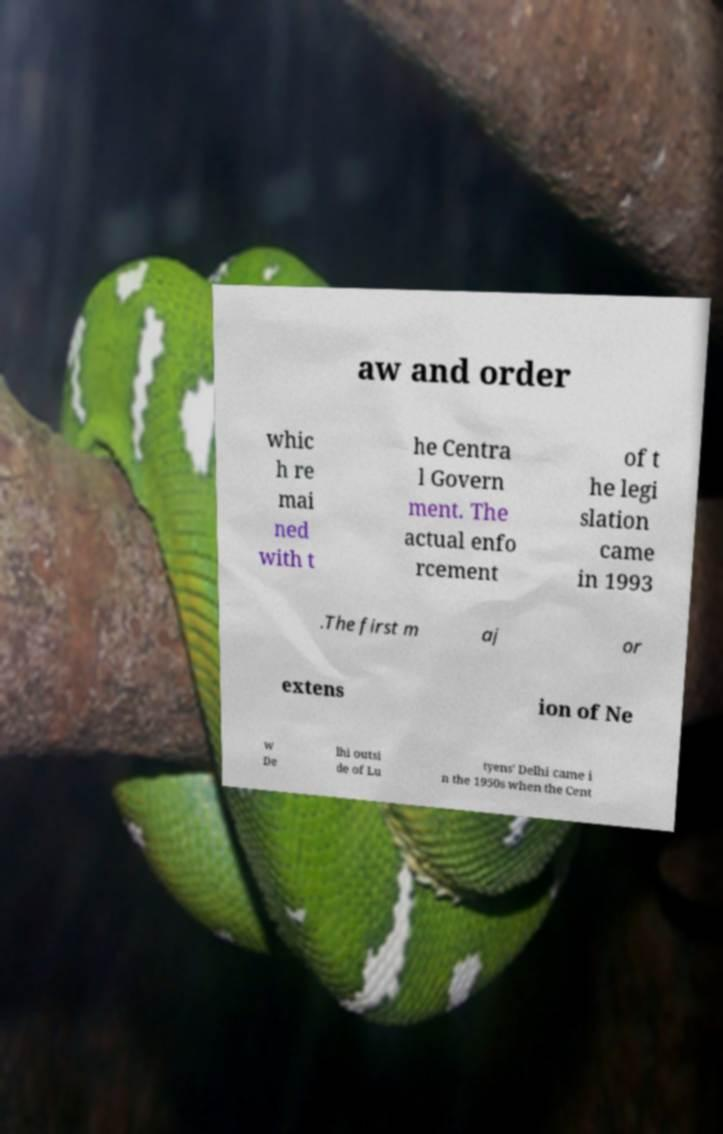For documentation purposes, I need the text within this image transcribed. Could you provide that? aw and order whic h re mai ned with t he Centra l Govern ment. The actual enfo rcement of t he legi slation came in 1993 .The first m aj or extens ion of Ne w De lhi outsi de of Lu tyens' Delhi came i n the 1950s when the Cent 